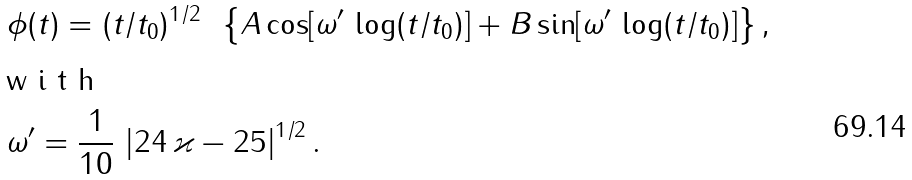<formula> <loc_0><loc_0><loc_500><loc_500>& \phi ( t ) = ( t / t _ { 0 } ) ^ { 1 / 2 } \, \ \left \{ A \cos [ \omega ^ { \prime } \, \log ( t / t _ { 0 } ) ] + B \sin [ \omega ^ { \prime } \, \log ( t / t _ { 0 } ) ] \right \} , \intertext { w i t h } & \omega ^ { \prime } = \frac { 1 } { 1 0 } \, \left | 2 4 \, \varkappa - 2 5 \right | ^ { 1 / 2 } .</formula> 